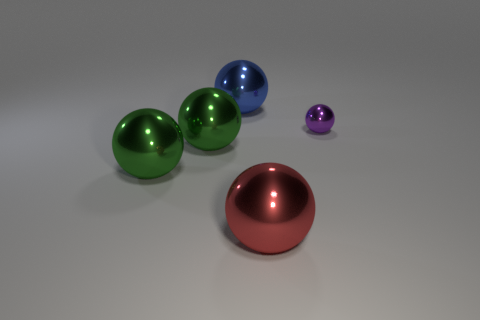Add 3 large red shiny objects. How many objects exist? 8 Subtract all red blocks. How many green balls are left? 2 Subtract all big green spheres. How many spheres are left? 3 Subtract all purple balls. How many balls are left? 4 Add 4 balls. How many balls exist? 9 Subtract 0 yellow cubes. How many objects are left? 5 Subtract all red balls. Subtract all brown cylinders. How many balls are left? 4 Subtract all big shiny balls. Subtract all big red spheres. How many objects are left? 0 Add 3 big blue objects. How many big blue objects are left? 4 